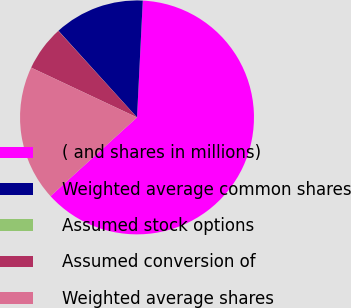<chart> <loc_0><loc_0><loc_500><loc_500><pie_chart><fcel>( and shares in millions)<fcel>Weighted average common shares<fcel>Assumed stock options<fcel>Assumed conversion of<fcel>Weighted average shares<nl><fcel>62.46%<fcel>12.51%<fcel>0.02%<fcel>6.26%<fcel>18.75%<nl></chart> 